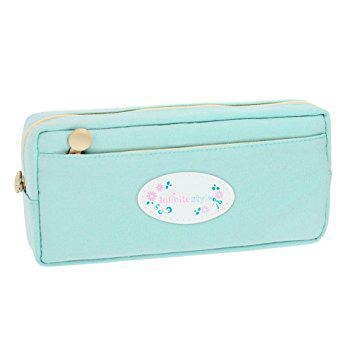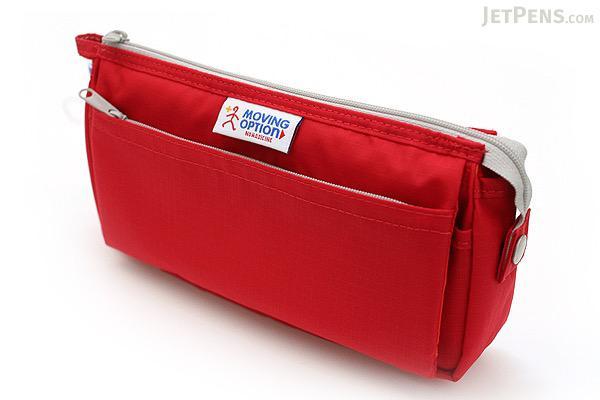The first image is the image on the left, the second image is the image on the right. Analyze the images presented: Is the assertion "There are at least 8 zippered pouches." valid? Answer yes or no. No. The first image is the image on the left, the second image is the image on the right. Analyze the images presented: Is the assertion "There are four bags/pencil-cases in the left image." valid? Answer yes or no. No. 